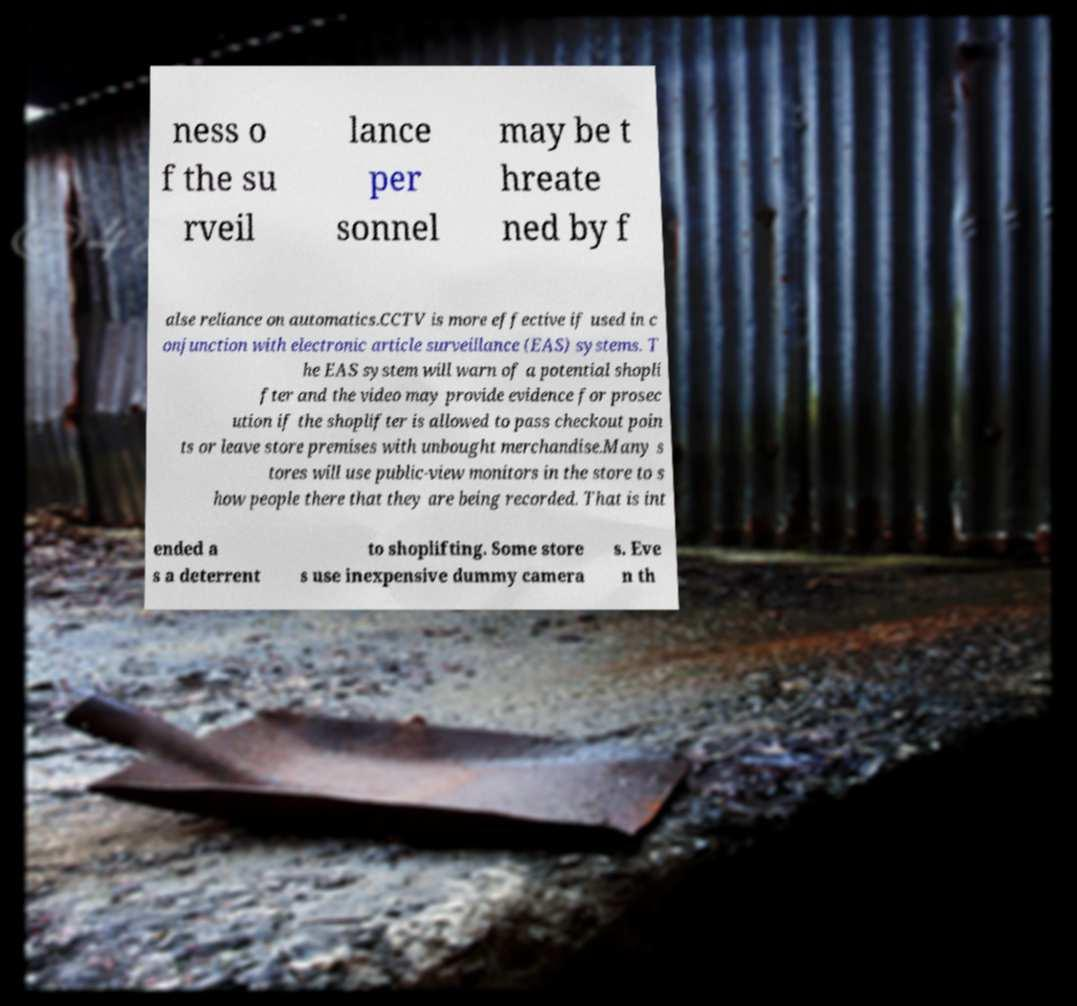What messages or text are displayed in this image? I need them in a readable, typed format. ness o f the su rveil lance per sonnel may be t hreate ned by f alse reliance on automatics.CCTV is more effective if used in c onjunction with electronic article surveillance (EAS) systems. T he EAS system will warn of a potential shopli fter and the video may provide evidence for prosec ution if the shoplifter is allowed to pass checkout poin ts or leave store premises with unbought merchandise.Many s tores will use public-view monitors in the store to s how people there that they are being recorded. That is int ended a s a deterrent to shoplifting. Some store s use inexpensive dummy camera s. Eve n th 